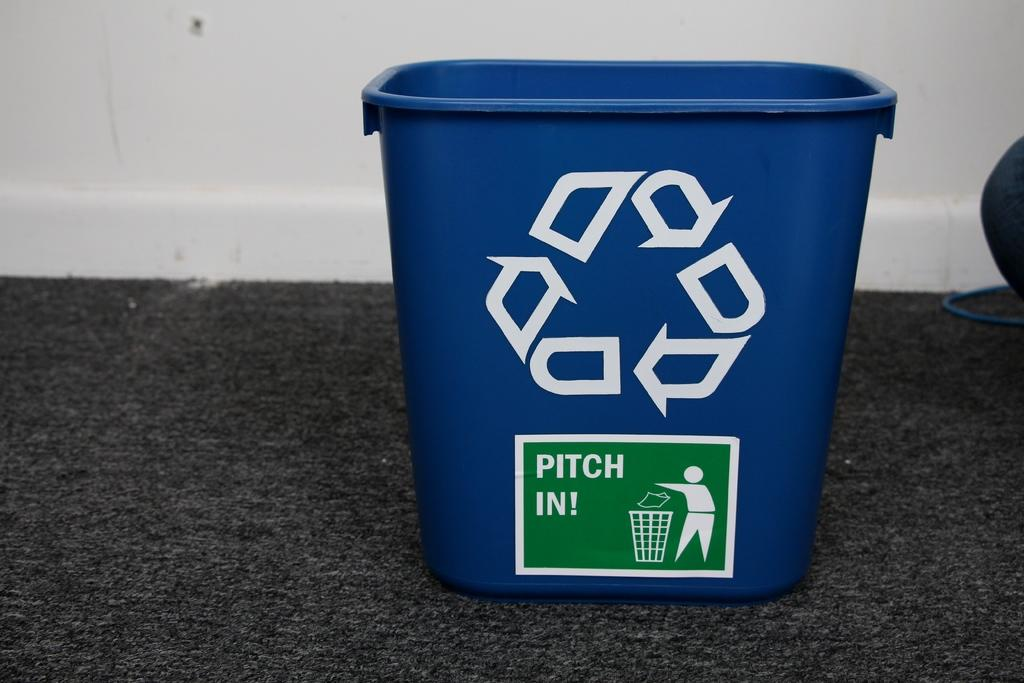<image>
Provide a brief description of the given image. A blue recycling bin that says Pitch In on some dark carpet. 